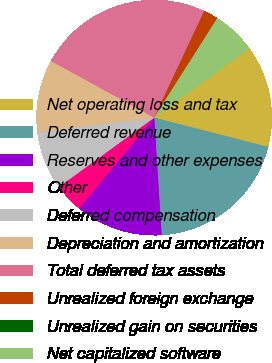Convert chart to OTSL. <chart><loc_0><loc_0><loc_500><loc_500><pie_chart><fcel>Net operating loss and tax<fcel>Deferred revenue<fcel>Reserves and other expenses<fcel>Other<fcel>Deferred compensation<fcel>Depreciation and amortization<fcel>Total deferred tax assets<fcel>Unrealized foreign exchange<fcel>Unrealized gain on securities<fcel>Net capitalized software<nl><fcel>14.0%<fcel>19.99%<fcel>12.0%<fcel>4.0%<fcel>8.0%<fcel>10.0%<fcel>23.99%<fcel>2.0%<fcel>0.01%<fcel>6.0%<nl></chart> 